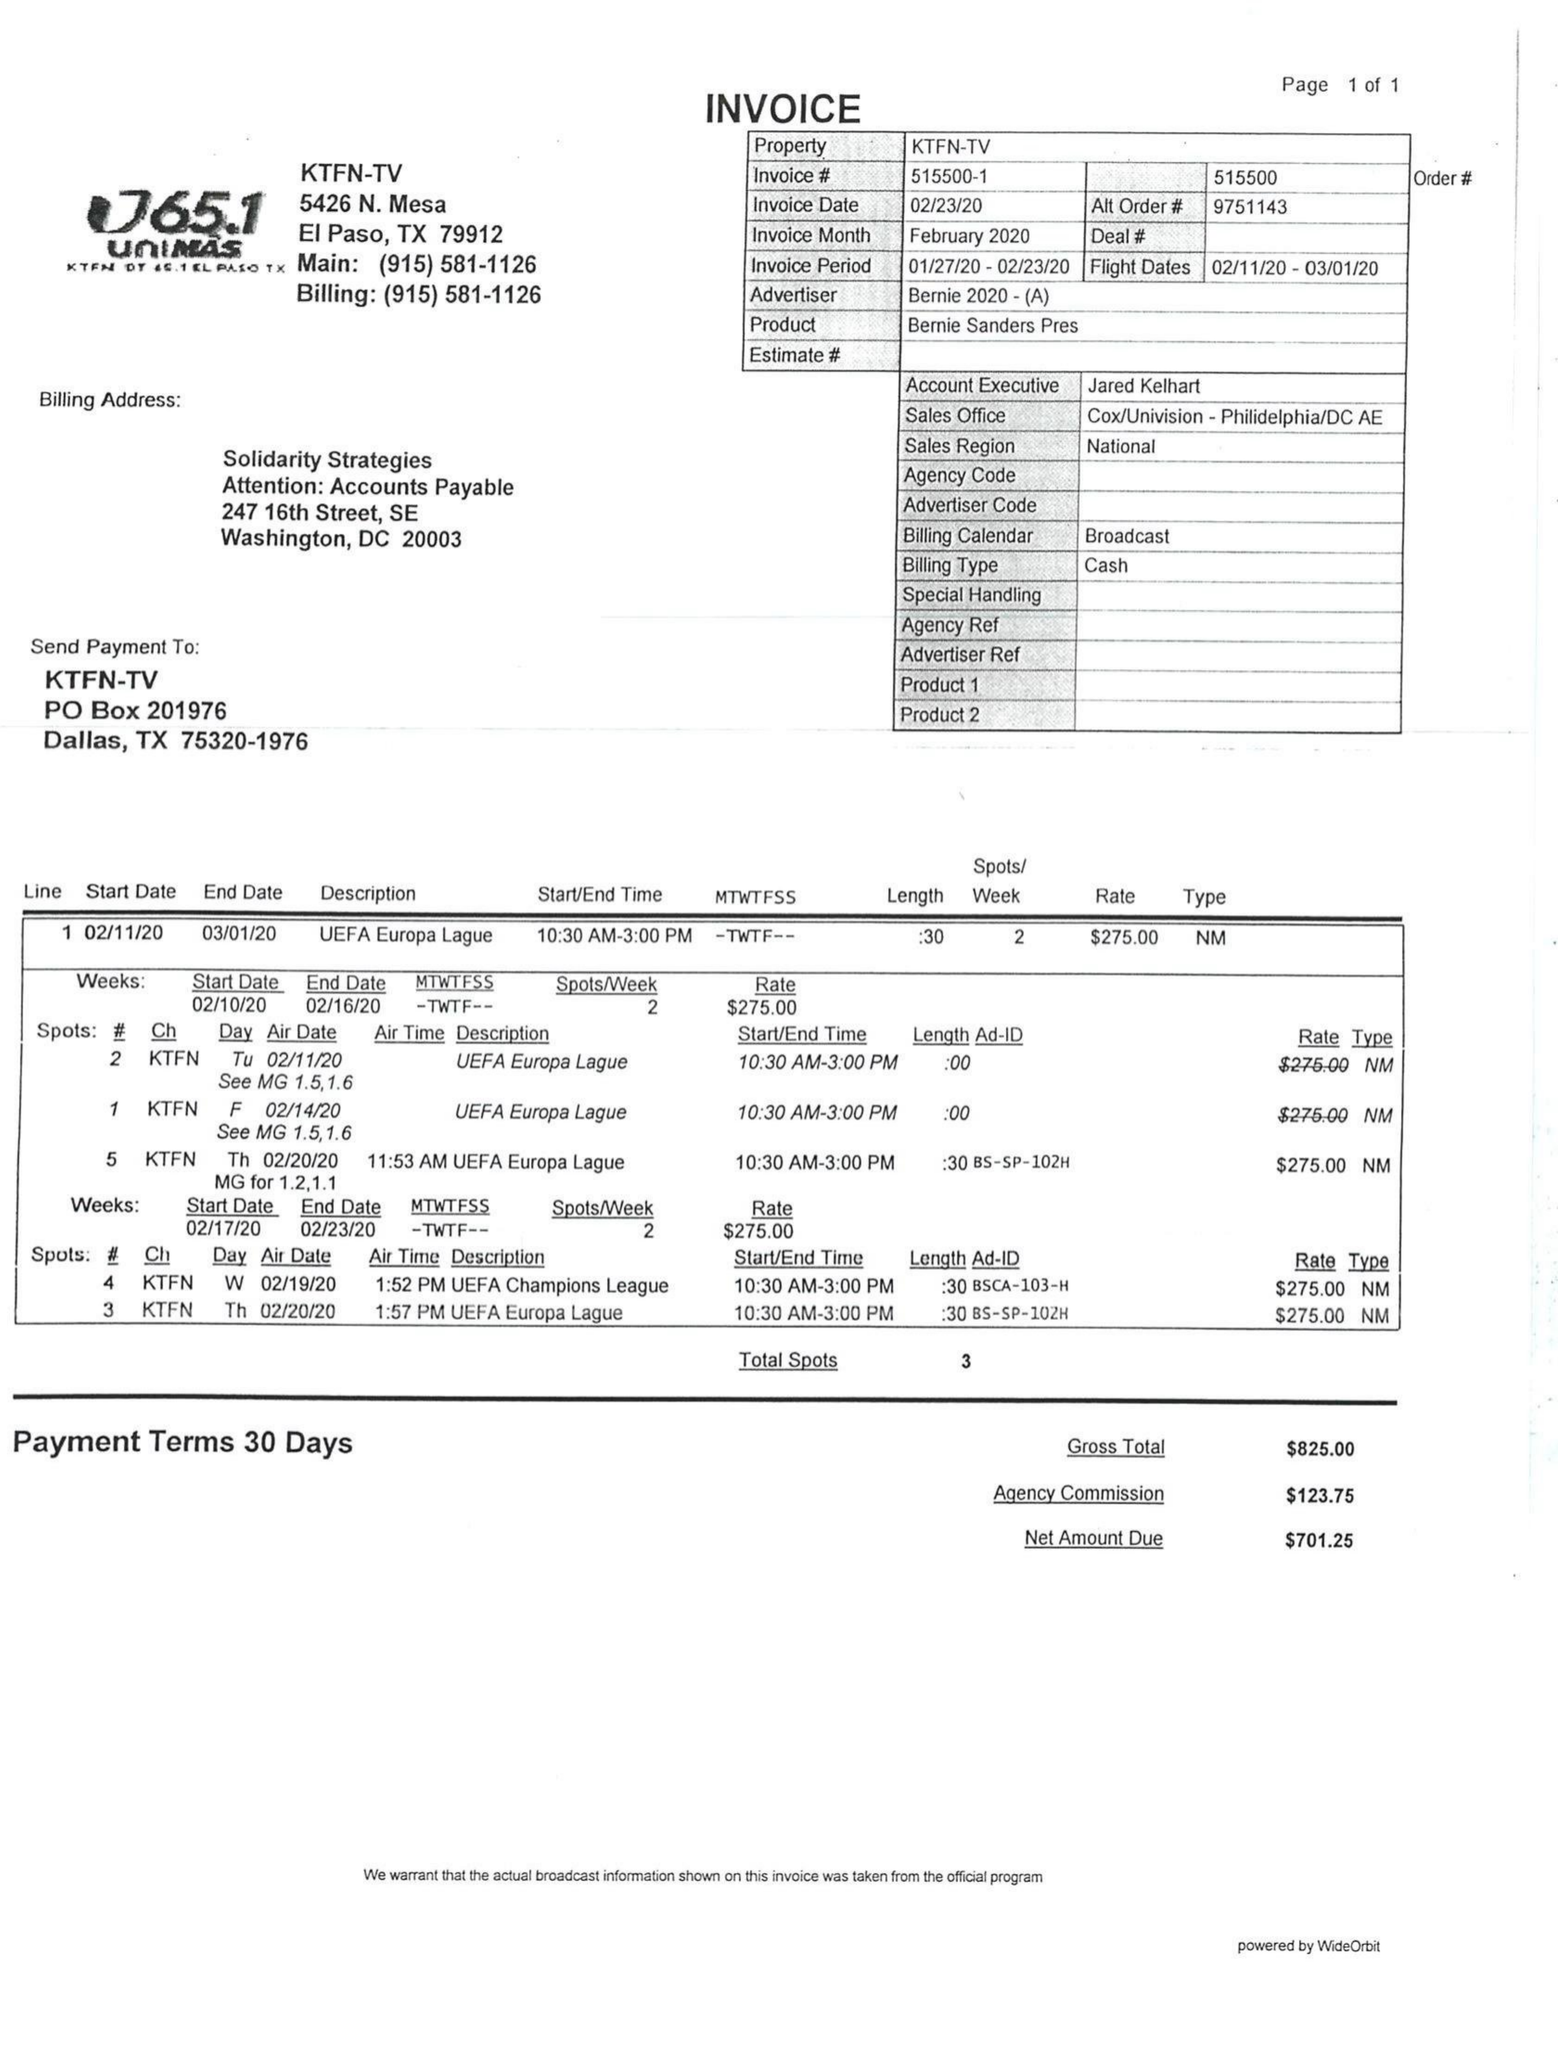What is the value for the flight_to?
Answer the question using a single word or phrase. 03/01/20 